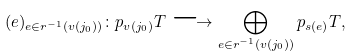<formula> <loc_0><loc_0><loc_500><loc_500>( e ) _ { e \in r ^ { - 1 } ( v ( j _ { 0 } ) ) } \colon p _ { v ( j _ { 0 } ) } T \longrightarrow \bigoplus _ { e \in r ^ { - 1 } ( v ( j _ { 0 } ) ) } { p _ { s ( e ) } } T ,</formula> 